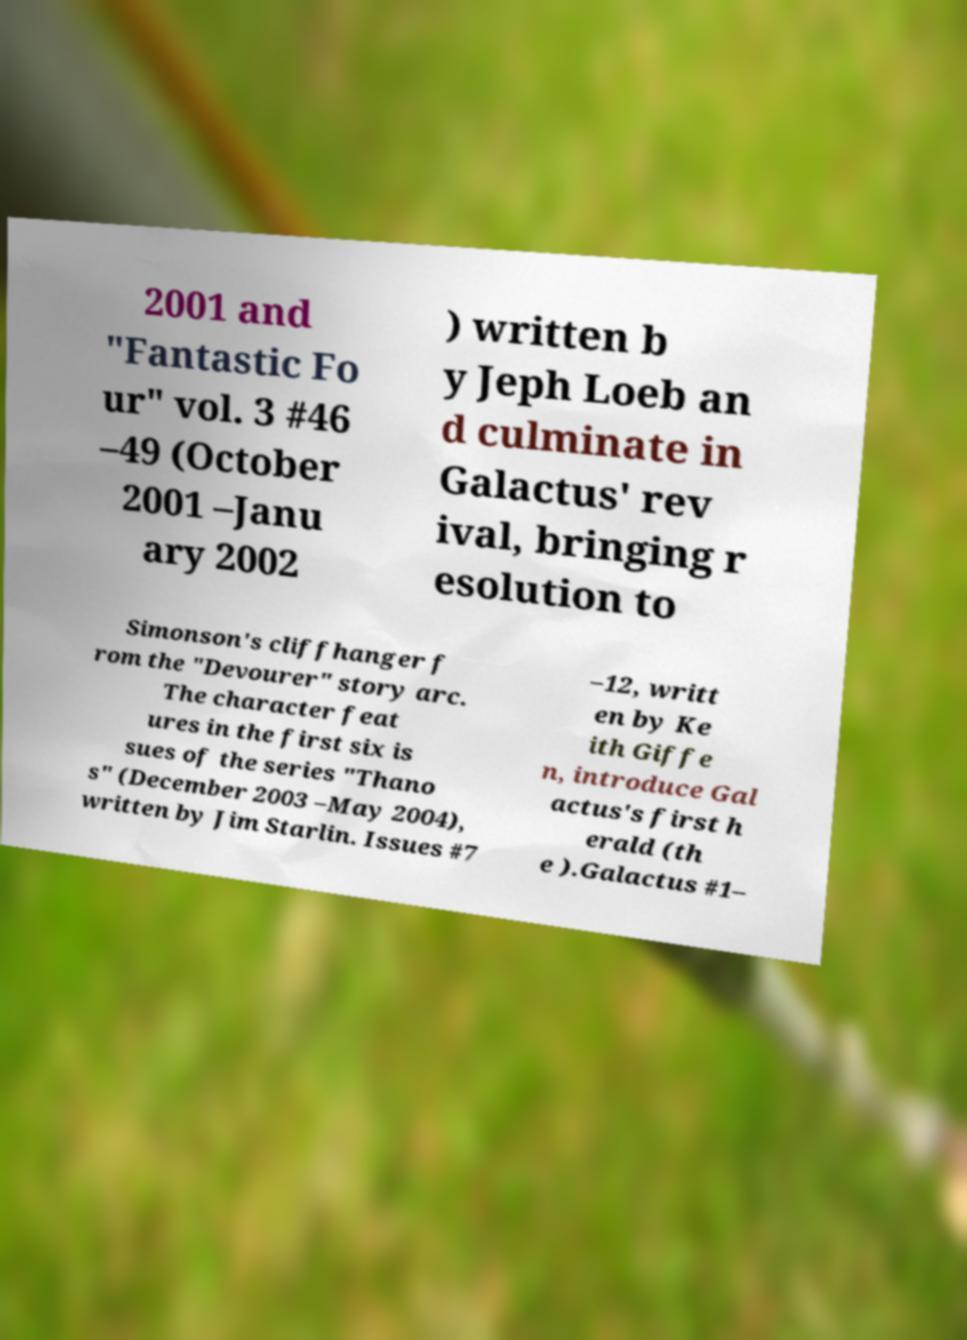Could you extract and type out the text from this image? 2001 and "Fantastic Fo ur" vol. 3 #46 –49 (October 2001 –Janu ary 2002 ) written b y Jeph Loeb an d culminate in Galactus' rev ival, bringing r esolution to Simonson's cliffhanger f rom the "Devourer" story arc. The character feat ures in the first six is sues of the series "Thano s" (December 2003 –May 2004), written by Jim Starlin. Issues #7 –12, writt en by Ke ith Giffe n, introduce Gal actus's first h erald (th e ).Galactus #1– 